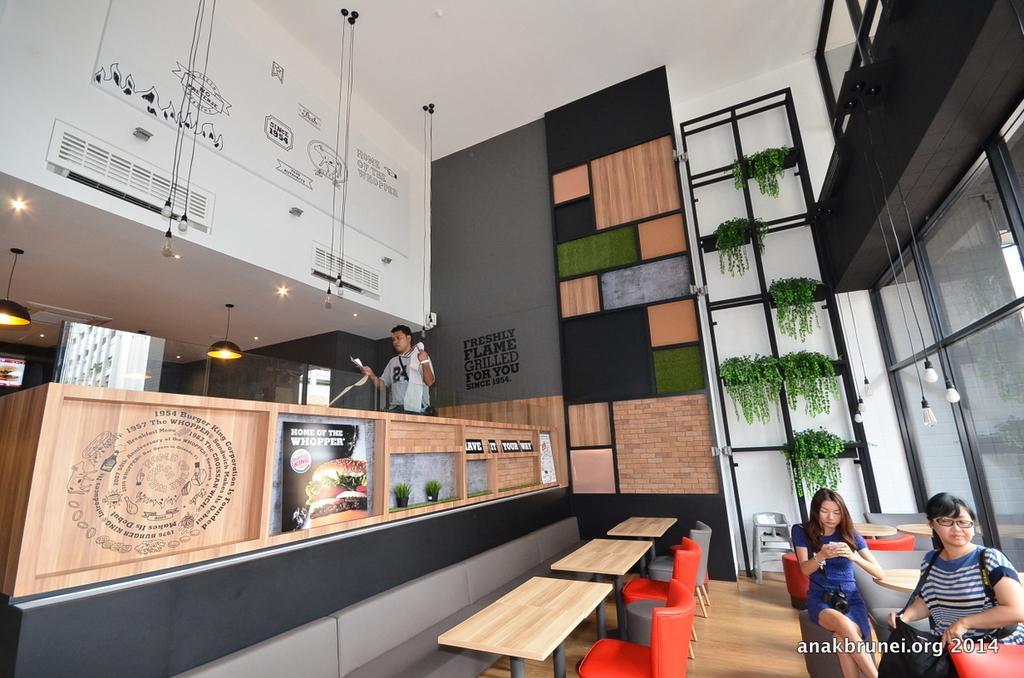In one or two sentences, can you explain what this image depicts? In the image on right side there are two women's sitting on chair in front of table. On left side we can see a man standing in middle there are some plants on top there is a roof with few lights. 